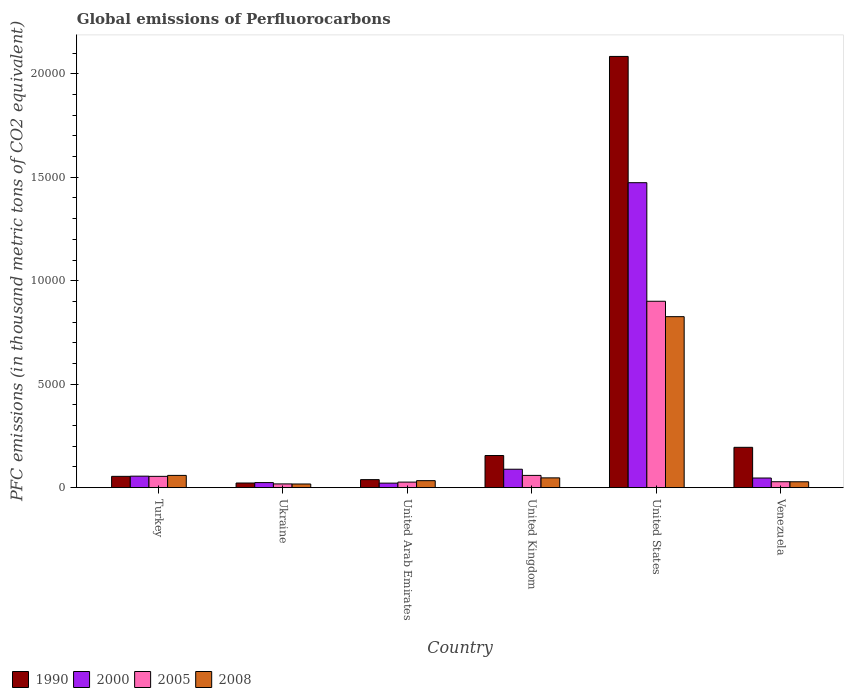How many different coloured bars are there?
Your response must be concise. 4. How many bars are there on the 1st tick from the right?
Offer a terse response. 4. What is the global emissions of Perfluorocarbons in 1990 in United Arab Emirates?
Provide a succinct answer. 387.3. Across all countries, what is the maximum global emissions of Perfluorocarbons in 2008?
Your response must be concise. 8264. Across all countries, what is the minimum global emissions of Perfluorocarbons in 2005?
Give a very brief answer. 180.5. In which country was the global emissions of Perfluorocarbons in 2005 minimum?
Offer a very short reply. Ukraine. What is the total global emissions of Perfluorocarbons in 2008 in the graph?
Give a very brief answer. 1.01e+04. What is the difference between the global emissions of Perfluorocarbons in 2008 in Turkey and that in United Kingdom?
Your answer should be very brief. 119. What is the difference between the global emissions of Perfluorocarbons in 2005 in United Arab Emirates and the global emissions of Perfluorocarbons in 2000 in Turkey?
Your answer should be very brief. -287. What is the average global emissions of Perfluorocarbons in 2005 per country?
Make the answer very short. 1813.42. What is the ratio of the global emissions of Perfluorocarbons in 2005 in United Arab Emirates to that in Venezuela?
Offer a terse response. 0.94. Is the global emissions of Perfluorocarbons in 2008 in United Arab Emirates less than that in United Kingdom?
Offer a terse response. Yes. Is the difference between the global emissions of Perfluorocarbons in 2000 in United Kingdom and Venezuela greater than the difference between the global emissions of Perfluorocarbons in 2005 in United Kingdom and Venezuela?
Your answer should be compact. Yes. What is the difference between the highest and the second highest global emissions of Perfluorocarbons in 2005?
Provide a short and direct response. 8462.8. What is the difference between the highest and the lowest global emissions of Perfluorocarbons in 2000?
Your answer should be very brief. 1.45e+04. In how many countries, is the global emissions of Perfluorocarbons in 2008 greater than the average global emissions of Perfluorocarbons in 2008 taken over all countries?
Your answer should be compact. 1. Is the sum of the global emissions of Perfluorocarbons in 2008 in United Arab Emirates and United States greater than the maximum global emissions of Perfluorocarbons in 1990 across all countries?
Your answer should be compact. No. Is it the case that in every country, the sum of the global emissions of Perfluorocarbons in 2008 and global emissions of Perfluorocarbons in 1990 is greater than the sum of global emissions of Perfluorocarbons in 2000 and global emissions of Perfluorocarbons in 2005?
Your answer should be compact. No. What does the 1st bar from the left in Venezuela represents?
Make the answer very short. 1990. What does the 4th bar from the right in Venezuela represents?
Provide a short and direct response. 1990. How many bars are there?
Your answer should be compact. 24. How many countries are there in the graph?
Ensure brevity in your answer.  6. What is the difference between two consecutive major ticks on the Y-axis?
Your answer should be very brief. 5000. Are the values on the major ticks of Y-axis written in scientific E-notation?
Offer a very short reply. No. Where does the legend appear in the graph?
Your answer should be compact. Bottom left. How many legend labels are there?
Provide a succinct answer. 4. How are the legend labels stacked?
Your answer should be compact. Horizontal. What is the title of the graph?
Your answer should be very brief. Global emissions of Perfluorocarbons. Does "1969" appear as one of the legend labels in the graph?
Offer a very short reply. No. What is the label or title of the X-axis?
Your answer should be very brief. Country. What is the label or title of the Y-axis?
Ensure brevity in your answer.  PFC emissions (in thousand metric tons of CO2 equivalent). What is the PFC emissions (in thousand metric tons of CO2 equivalent) of 1990 in Turkey?
Offer a terse response. 545.6. What is the PFC emissions (in thousand metric tons of CO2 equivalent) in 2000 in Turkey?
Provide a succinct answer. 554.9. What is the PFC emissions (in thousand metric tons of CO2 equivalent) of 2005 in Turkey?
Offer a very short reply. 545.9. What is the PFC emissions (in thousand metric tons of CO2 equivalent) in 2008 in Turkey?
Offer a very short reply. 591.4. What is the PFC emissions (in thousand metric tons of CO2 equivalent) in 1990 in Ukraine?
Provide a succinct answer. 224. What is the PFC emissions (in thousand metric tons of CO2 equivalent) in 2000 in Ukraine?
Provide a short and direct response. 244.1. What is the PFC emissions (in thousand metric tons of CO2 equivalent) of 2005 in Ukraine?
Provide a short and direct response. 180.5. What is the PFC emissions (in thousand metric tons of CO2 equivalent) of 2008 in Ukraine?
Your response must be concise. 176.5. What is the PFC emissions (in thousand metric tons of CO2 equivalent) of 1990 in United Arab Emirates?
Your answer should be compact. 387.3. What is the PFC emissions (in thousand metric tons of CO2 equivalent) of 2000 in United Arab Emirates?
Your answer should be compact. 218. What is the PFC emissions (in thousand metric tons of CO2 equivalent) of 2005 in United Arab Emirates?
Provide a succinct answer. 267.9. What is the PFC emissions (in thousand metric tons of CO2 equivalent) in 2008 in United Arab Emirates?
Your answer should be very brief. 337.6. What is the PFC emissions (in thousand metric tons of CO2 equivalent) in 1990 in United Kingdom?
Keep it short and to the point. 1552.5. What is the PFC emissions (in thousand metric tons of CO2 equivalent) of 2000 in United Kingdom?
Give a very brief answer. 890.1. What is the PFC emissions (in thousand metric tons of CO2 equivalent) of 2005 in United Kingdom?
Keep it short and to the point. 591.4. What is the PFC emissions (in thousand metric tons of CO2 equivalent) in 2008 in United Kingdom?
Your answer should be compact. 472.4. What is the PFC emissions (in thousand metric tons of CO2 equivalent) in 1990 in United States?
Your response must be concise. 2.08e+04. What is the PFC emissions (in thousand metric tons of CO2 equivalent) in 2000 in United States?
Offer a terse response. 1.47e+04. What is the PFC emissions (in thousand metric tons of CO2 equivalent) in 2005 in United States?
Provide a short and direct response. 9008.7. What is the PFC emissions (in thousand metric tons of CO2 equivalent) of 2008 in United States?
Provide a succinct answer. 8264. What is the PFC emissions (in thousand metric tons of CO2 equivalent) in 1990 in Venezuela?
Your answer should be compact. 1948.7. What is the PFC emissions (in thousand metric tons of CO2 equivalent) of 2000 in Venezuela?
Provide a short and direct response. 464.6. What is the PFC emissions (in thousand metric tons of CO2 equivalent) of 2005 in Venezuela?
Your answer should be compact. 286.1. What is the PFC emissions (in thousand metric tons of CO2 equivalent) in 2008 in Venezuela?
Provide a short and direct response. 283.8. Across all countries, what is the maximum PFC emissions (in thousand metric tons of CO2 equivalent) of 1990?
Your answer should be compact. 2.08e+04. Across all countries, what is the maximum PFC emissions (in thousand metric tons of CO2 equivalent) in 2000?
Keep it short and to the point. 1.47e+04. Across all countries, what is the maximum PFC emissions (in thousand metric tons of CO2 equivalent) of 2005?
Ensure brevity in your answer.  9008.7. Across all countries, what is the maximum PFC emissions (in thousand metric tons of CO2 equivalent) in 2008?
Ensure brevity in your answer.  8264. Across all countries, what is the minimum PFC emissions (in thousand metric tons of CO2 equivalent) in 1990?
Your answer should be very brief. 224. Across all countries, what is the minimum PFC emissions (in thousand metric tons of CO2 equivalent) of 2000?
Your answer should be compact. 218. Across all countries, what is the minimum PFC emissions (in thousand metric tons of CO2 equivalent) in 2005?
Your response must be concise. 180.5. Across all countries, what is the minimum PFC emissions (in thousand metric tons of CO2 equivalent) in 2008?
Your answer should be very brief. 176.5. What is the total PFC emissions (in thousand metric tons of CO2 equivalent) of 1990 in the graph?
Make the answer very short. 2.55e+04. What is the total PFC emissions (in thousand metric tons of CO2 equivalent) of 2000 in the graph?
Provide a short and direct response. 1.71e+04. What is the total PFC emissions (in thousand metric tons of CO2 equivalent) of 2005 in the graph?
Your response must be concise. 1.09e+04. What is the total PFC emissions (in thousand metric tons of CO2 equivalent) of 2008 in the graph?
Keep it short and to the point. 1.01e+04. What is the difference between the PFC emissions (in thousand metric tons of CO2 equivalent) of 1990 in Turkey and that in Ukraine?
Give a very brief answer. 321.6. What is the difference between the PFC emissions (in thousand metric tons of CO2 equivalent) of 2000 in Turkey and that in Ukraine?
Offer a very short reply. 310.8. What is the difference between the PFC emissions (in thousand metric tons of CO2 equivalent) of 2005 in Turkey and that in Ukraine?
Keep it short and to the point. 365.4. What is the difference between the PFC emissions (in thousand metric tons of CO2 equivalent) in 2008 in Turkey and that in Ukraine?
Offer a very short reply. 414.9. What is the difference between the PFC emissions (in thousand metric tons of CO2 equivalent) of 1990 in Turkey and that in United Arab Emirates?
Ensure brevity in your answer.  158.3. What is the difference between the PFC emissions (in thousand metric tons of CO2 equivalent) in 2000 in Turkey and that in United Arab Emirates?
Ensure brevity in your answer.  336.9. What is the difference between the PFC emissions (in thousand metric tons of CO2 equivalent) in 2005 in Turkey and that in United Arab Emirates?
Offer a terse response. 278. What is the difference between the PFC emissions (in thousand metric tons of CO2 equivalent) in 2008 in Turkey and that in United Arab Emirates?
Offer a terse response. 253.8. What is the difference between the PFC emissions (in thousand metric tons of CO2 equivalent) in 1990 in Turkey and that in United Kingdom?
Your answer should be compact. -1006.9. What is the difference between the PFC emissions (in thousand metric tons of CO2 equivalent) in 2000 in Turkey and that in United Kingdom?
Give a very brief answer. -335.2. What is the difference between the PFC emissions (in thousand metric tons of CO2 equivalent) of 2005 in Turkey and that in United Kingdom?
Provide a short and direct response. -45.5. What is the difference between the PFC emissions (in thousand metric tons of CO2 equivalent) in 2008 in Turkey and that in United Kingdom?
Provide a short and direct response. 119. What is the difference between the PFC emissions (in thousand metric tons of CO2 equivalent) in 1990 in Turkey and that in United States?
Ensure brevity in your answer.  -2.03e+04. What is the difference between the PFC emissions (in thousand metric tons of CO2 equivalent) in 2000 in Turkey and that in United States?
Keep it short and to the point. -1.42e+04. What is the difference between the PFC emissions (in thousand metric tons of CO2 equivalent) of 2005 in Turkey and that in United States?
Your answer should be compact. -8462.8. What is the difference between the PFC emissions (in thousand metric tons of CO2 equivalent) in 2008 in Turkey and that in United States?
Give a very brief answer. -7672.6. What is the difference between the PFC emissions (in thousand metric tons of CO2 equivalent) of 1990 in Turkey and that in Venezuela?
Provide a short and direct response. -1403.1. What is the difference between the PFC emissions (in thousand metric tons of CO2 equivalent) of 2000 in Turkey and that in Venezuela?
Provide a short and direct response. 90.3. What is the difference between the PFC emissions (in thousand metric tons of CO2 equivalent) of 2005 in Turkey and that in Venezuela?
Make the answer very short. 259.8. What is the difference between the PFC emissions (in thousand metric tons of CO2 equivalent) in 2008 in Turkey and that in Venezuela?
Give a very brief answer. 307.6. What is the difference between the PFC emissions (in thousand metric tons of CO2 equivalent) in 1990 in Ukraine and that in United Arab Emirates?
Offer a very short reply. -163.3. What is the difference between the PFC emissions (in thousand metric tons of CO2 equivalent) in 2000 in Ukraine and that in United Arab Emirates?
Ensure brevity in your answer.  26.1. What is the difference between the PFC emissions (in thousand metric tons of CO2 equivalent) of 2005 in Ukraine and that in United Arab Emirates?
Provide a succinct answer. -87.4. What is the difference between the PFC emissions (in thousand metric tons of CO2 equivalent) of 2008 in Ukraine and that in United Arab Emirates?
Your answer should be very brief. -161.1. What is the difference between the PFC emissions (in thousand metric tons of CO2 equivalent) in 1990 in Ukraine and that in United Kingdom?
Your answer should be very brief. -1328.5. What is the difference between the PFC emissions (in thousand metric tons of CO2 equivalent) of 2000 in Ukraine and that in United Kingdom?
Provide a succinct answer. -646. What is the difference between the PFC emissions (in thousand metric tons of CO2 equivalent) of 2005 in Ukraine and that in United Kingdom?
Your response must be concise. -410.9. What is the difference between the PFC emissions (in thousand metric tons of CO2 equivalent) in 2008 in Ukraine and that in United Kingdom?
Your answer should be compact. -295.9. What is the difference between the PFC emissions (in thousand metric tons of CO2 equivalent) in 1990 in Ukraine and that in United States?
Ensure brevity in your answer.  -2.06e+04. What is the difference between the PFC emissions (in thousand metric tons of CO2 equivalent) of 2000 in Ukraine and that in United States?
Your answer should be very brief. -1.45e+04. What is the difference between the PFC emissions (in thousand metric tons of CO2 equivalent) in 2005 in Ukraine and that in United States?
Ensure brevity in your answer.  -8828.2. What is the difference between the PFC emissions (in thousand metric tons of CO2 equivalent) in 2008 in Ukraine and that in United States?
Ensure brevity in your answer.  -8087.5. What is the difference between the PFC emissions (in thousand metric tons of CO2 equivalent) in 1990 in Ukraine and that in Venezuela?
Your answer should be very brief. -1724.7. What is the difference between the PFC emissions (in thousand metric tons of CO2 equivalent) of 2000 in Ukraine and that in Venezuela?
Your response must be concise. -220.5. What is the difference between the PFC emissions (in thousand metric tons of CO2 equivalent) of 2005 in Ukraine and that in Venezuela?
Provide a succinct answer. -105.6. What is the difference between the PFC emissions (in thousand metric tons of CO2 equivalent) of 2008 in Ukraine and that in Venezuela?
Your answer should be very brief. -107.3. What is the difference between the PFC emissions (in thousand metric tons of CO2 equivalent) of 1990 in United Arab Emirates and that in United Kingdom?
Ensure brevity in your answer.  -1165.2. What is the difference between the PFC emissions (in thousand metric tons of CO2 equivalent) in 2000 in United Arab Emirates and that in United Kingdom?
Provide a succinct answer. -672.1. What is the difference between the PFC emissions (in thousand metric tons of CO2 equivalent) of 2005 in United Arab Emirates and that in United Kingdom?
Provide a short and direct response. -323.5. What is the difference between the PFC emissions (in thousand metric tons of CO2 equivalent) in 2008 in United Arab Emirates and that in United Kingdom?
Provide a succinct answer. -134.8. What is the difference between the PFC emissions (in thousand metric tons of CO2 equivalent) of 1990 in United Arab Emirates and that in United States?
Provide a short and direct response. -2.05e+04. What is the difference between the PFC emissions (in thousand metric tons of CO2 equivalent) of 2000 in United Arab Emirates and that in United States?
Keep it short and to the point. -1.45e+04. What is the difference between the PFC emissions (in thousand metric tons of CO2 equivalent) in 2005 in United Arab Emirates and that in United States?
Offer a terse response. -8740.8. What is the difference between the PFC emissions (in thousand metric tons of CO2 equivalent) in 2008 in United Arab Emirates and that in United States?
Offer a very short reply. -7926.4. What is the difference between the PFC emissions (in thousand metric tons of CO2 equivalent) of 1990 in United Arab Emirates and that in Venezuela?
Provide a short and direct response. -1561.4. What is the difference between the PFC emissions (in thousand metric tons of CO2 equivalent) in 2000 in United Arab Emirates and that in Venezuela?
Ensure brevity in your answer.  -246.6. What is the difference between the PFC emissions (in thousand metric tons of CO2 equivalent) of 2005 in United Arab Emirates and that in Venezuela?
Keep it short and to the point. -18.2. What is the difference between the PFC emissions (in thousand metric tons of CO2 equivalent) of 2008 in United Arab Emirates and that in Venezuela?
Your response must be concise. 53.8. What is the difference between the PFC emissions (in thousand metric tons of CO2 equivalent) in 1990 in United Kingdom and that in United States?
Your answer should be compact. -1.93e+04. What is the difference between the PFC emissions (in thousand metric tons of CO2 equivalent) in 2000 in United Kingdom and that in United States?
Provide a short and direct response. -1.38e+04. What is the difference between the PFC emissions (in thousand metric tons of CO2 equivalent) in 2005 in United Kingdom and that in United States?
Provide a short and direct response. -8417.3. What is the difference between the PFC emissions (in thousand metric tons of CO2 equivalent) in 2008 in United Kingdom and that in United States?
Provide a succinct answer. -7791.6. What is the difference between the PFC emissions (in thousand metric tons of CO2 equivalent) in 1990 in United Kingdom and that in Venezuela?
Provide a succinct answer. -396.2. What is the difference between the PFC emissions (in thousand metric tons of CO2 equivalent) of 2000 in United Kingdom and that in Venezuela?
Your answer should be compact. 425.5. What is the difference between the PFC emissions (in thousand metric tons of CO2 equivalent) of 2005 in United Kingdom and that in Venezuela?
Make the answer very short. 305.3. What is the difference between the PFC emissions (in thousand metric tons of CO2 equivalent) of 2008 in United Kingdom and that in Venezuela?
Keep it short and to the point. 188.6. What is the difference between the PFC emissions (in thousand metric tons of CO2 equivalent) of 1990 in United States and that in Venezuela?
Keep it short and to the point. 1.89e+04. What is the difference between the PFC emissions (in thousand metric tons of CO2 equivalent) of 2000 in United States and that in Venezuela?
Ensure brevity in your answer.  1.43e+04. What is the difference between the PFC emissions (in thousand metric tons of CO2 equivalent) of 2005 in United States and that in Venezuela?
Your response must be concise. 8722.6. What is the difference between the PFC emissions (in thousand metric tons of CO2 equivalent) of 2008 in United States and that in Venezuela?
Keep it short and to the point. 7980.2. What is the difference between the PFC emissions (in thousand metric tons of CO2 equivalent) in 1990 in Turkey and the PFC emissions (in thousand metric tons of CO2 equivalent) in 2000 in Ukraine?
Your answer should be compact. 301.5. What is the difference between the PFC emissions (in thousand metric tons of CO2 equivalent) in 1990 in Turkey and the PFC emissions (in thousand metric tons of CO2 equivalent) in 2005 in Ukraine?
Make the answer very short. 365.1. What is the difference between the PFC emissions (in thousand metric tons of CO2 equivalent) of 1990 in Turkey and the PFC emissions (in thousand metric tons of CO2 equivalent) of 2008 in Ukraine?
Your answer should be compact. 369.1. What is the difference between the PFC emissions (in thousand metric tons of CO2 equivalent) in 2000 in Turkey and the PFC emissions (in thousand metric tons of CO2 equivalent) in 2005 in Ukraine?
Provide a succinct answer. 374.4. What is the difference between the PFC emissions (in thousand metric tons of CO2 equivalent) of 2000 in Turkey and the PFC emissions (in thousand metric tons of CO2 equivalent) of 2008 in Ukraine?
Provide a short and direct response. 378.4. What is the difference between the PFC emissions (in thousand metric tons of CO2 equivalent) of 2005 in Turkey and the PFC emissions (in thousand metric tons of CO2 equivalent) of 2008 in Ukraine?
Your response must be concise. 369.4. What is the difference between the PFC emissions (in thousand metric tons of CO2 equivalent) of 1990 in Turkey and the PFC emissions (in thousand metric tons of CO2 equivalent) of 2000 in United Arab Emirates?
Give a very brief answer. 327.6. What is the difference between the PFC emissions (in thousand metric tons of CO2 equivalent) in 1990 in Turkey and the PFC emissions (in thousand metric tons of CO2 equivalent) in 2005 in United Arab Emirates?
Your answer should be very brief. 277.7. What is the difference between the PFC emissions (in thousand metric tons of CO2 equivalent) of 1990 in Turkey and the PFC emissions (in thousand metric tons of CO2 equivalent) of 2008 in United Arab Emirates?
Your response must be concise. 208. What is the difference between the PFC emissions (in thousand metric tons of CO2 equivalent) in 2000 in Turkey and the PFC emissions (in thousand metric tons of CO2 equivalent) in 2005 in United Arab Emirates?
Ensure brevity in your answer.  287. What is the difference between the PFC emissions (in thousand metric tons of CO2 equivalent) of 2000 in Turkey and the PFC emissions (in thousand metric tons of CO2 equivalent) of 2008 in United Arab Emirates?
Your answer should be very brief. 217.3. What is the difference between the PFC emissions (in thousand metric tons of CO2 equivalent) in 2005 in Turkey and the PFC emissions (in thousand metric tons of CO2 equivalent) in 2008 in United Arab Emirates?
Offer a terse response. 208.3. What is the difference between the PFC emissions (in thousand metric tons of CO2 equivalent) of 1990 in Turkey and the PFC emissions (in thousand metric tons of CO2 equivalent) of 2000 in United Kingdom?
Your answer should be compact. -344.5. What is the difference between the PFC emissions (in thousand metric tons of CO2 equivalent) of 1990 in Turkey and the PFC emissions (in thousand metric tons of CO2 equivalent) of 2005 in United Kingdom?
Offer a terse response. -45.8. What is the difference between the PFC emissions (in thousand metric tons of CO2 equivalent) of 1990 in Turkey and the PFC emissions (in thousand metric tons of CO2 equivalent) of 2008 in United Kingdom?
Provide a short and direct response. 73.2. What is the difference between the PFC emissions (in thousand metric tons of CO2 equivalent) of 2000 in Turkey and the PFC emissions (in thousand metric tons of CO2 equivalent) of 2005 in United Kingdom?
Your answer should be very brief. -36.5. What is the difference between the PFC emissions (in thousand metric tons of CO2 equivalent) of 2000 in Turkey and the PFC emissions (in thousand metric tons of CO2 equivalent) of 2008 in United Kingdom?
Keep it short and to the point. 82.5. What is the difference between the PFC emissions (in thousand metric tons of CO2 equivalent) in 2005 in Turkey and the PFC emissions (in thousand metric tons of CO2 equivalent) in 2008 in United Kingdom?
Ensure brevity in your answer.  73.5. What is the difference between the PFC emissions (in thousand metric tons of CO2 equivalent) in 1990 in Turkey and the PFC emissions (in thousand metric tons of CO2 equivalent) in 2000 in United States?
Offer a very short reply. -1.42e+04. What is the difference between the PFC emissions (in thousand metric tons of CO2 equivalent) of 1990 in Turkey and the PFC emissions (in thousand metric tons of CO2 equivalent) of 2005 in United States?
Make the answer very short. -8463.1. What is the difference between the PFC emissions (in thousand metric tons of CO2 equivalent) in 1990 in Turkey and the PFC emissions (in thousand metric tons of CO2 equivalent) in 2008 in United States?
Give a very brief answer. -7718.4. What is the difference between the PFC emissions (in thousand metric tons of CO2 equivalent) in 2000 in Turkey and the PFC emissions (in thousand metric tons of CO2 equivalent) in 2005 in United States?
Offer a very short reply. -8453.8. What is the difference between the PFC emissions (in thousand metric tons of CO2 equivalent) of 2000 in Turkey and the PFC emissions (in thousand metric tons of CO2 equivalent) of 2008 in United States?
Make the answer very short. -7709.1. What is the difference between the PFC emissions (in thousand metric tons of CO2 equivalent) of 2005 in Turkey and the PFC emissions (in thousand metric tons of CO2 equivalent) of 2008 in United States?
Your answer should be compact. -7718.1. What is the difference between the PFC emissions (in thousand metric tons of CO2 equivalent) of 1990 in Turkey and the PFC emissions (in thousand metric tons of CO2 equivalent) of 2005 in Venezuela?
Your response must be concise. 259.5. What is the difference between the PFC emissions (in thousand metric tons of CO2 equivalent) in 1990 in Turkey and the PFC emissions (in thousand metric tons of CO2 equivalent) in 2008 in Venezuela?
Ensure brevity in your answer.  261.8. What is the difference between the PFC emissions (in thousand metric tons of CO2 equivalent) of 2000 in Turkey and the PFC emissions (in thousand metric tons of CO2 equivalent) of 2005 in Venezuela?
Your answer should be compact. 268.8. What is the difference between the PFC emissions (in thousand metric tons of CO2 equivalent) of 2000 in Turkey and the PFC emissions (in thousand metric tons of CO2 equivalent) of 2008 in Venezuela?
Your response must be concise. 271.1. What is the difference between the PFC emissions (in thousand metric tons of CO2 equivalent) of 2005 in Turkey and the PFC emissions (in thousand metric tons of CO2 equivalent) of 2008 in Venezuela?
Keep it short and to the point. 262.1. What is the difference between the PFC emissions (in thousand metric tons of CO2 equivalent) in 1990 in Ukraine and the PFC emissions (in thousand metric tons of CO2 equivalent) in 2005 in United Arab Emirates?
Make the answer very short. -43.9. What is the difference between the PFC emissions (in thousand metric tons of CO2 equivalent) of 1990 in Ukraine and the PFC emissions (in thousand metric tons of CO2 equivalent) of 2008 in United Arab Emirates?
Offer a terse response. -113.6. What is the difference between the PFC emissions (in thousand metric tons of CO2 equivalent) in 2000 in Ukraine and the PFC emissions (in thousand metric tons of CO2 equivalent) in 2005 in United Arab Emirates?
Provide a short and direct response. -23.8. What is the difference between the PFC emissions (in thousand metric tons of CO2 equivalent) of 2000 in Ukraine and the PFC emissions (in thousand metric tons of CO2 equivalent) of 2008 in United Arab Emirates?
Give a very brief answer. -93.5. What is the difference between the PFC emissions (in thousand metric tons of CO2 equivalent) of 2005 in Ukraine and the PFC emissions (in thousand metric tons of CO2 equivalent) of 2008 in United Arab Emirates?
Make the answer very short. -157.1. What is the difference between the PFC emissions (in thousand metric tons of CO2 equivalent) in 1990 in Ukraine and the PFC emissions (in thousand metric tons of CO2 equivalent) in 2000 in United Kingdom?
Your response must be concise. -666.1. What is the difference between the PFC emissions (in thousand metric tons of CO2 equivalent) of 1990 in Ukraine and the PFC emissions (in thousand metric tons of CO2 equivalent) of 2005 in United Kingdom?
Offer a very short reply. -367.4. What is the difference between the PFC emissions (in thousand metric tons of CO2 equivalent) in 1990 in Ukraine and the PFC emissions (in thousand metric tons of CO2 equivalent) in 2008 in United Kingdom?
Provide a succinct answer. -248.4. What is the difference between the PFC emissions (in thousand metric tons of CO2 equivalent) in 2000 in Ukraine and the PFC emissions (in thousand metric tons of CO2 equivalent) in 2005 in United Kingdom?
Provide a succinct answer. -347.3. What is the difference between the PFC emissions (in thousand metric tons of CO2 equivalent) of 2000 in Ukraine and the PFC emissions (in thousand metric tons of CO2 equivalent) of 2008 in United Kingdom?
Offer a very short reply. -228.3. What is the difference between the PFC emissions (in thousand metric tons of CO2 equivalent) in 2005 in Ukraine and the PFC emissions (in thousand metric tons of CO2 equivalent) in 2008 in United Kingdom?
Offer a terse response. -291.9. What is the difference between the PFC emissions (in thousand metric tons of CO2 equivalent) in 1990 in Ukraine and the PFC emissions (in thousand metric tons of CO2 equivalent) in 2000 in United States?
Provide a short and direct response. -1.45e+04. What is the difference between the PFC emissions (in thousand metric tons of CO2 equivalent) of 1990 in Ukraine and the PFC emissions (in thousand metric tons of CO2 equivalent) of 2005 in United States?
Your response must be concise. -8784.7. What is the difference between the PFC emissions (in thousand metric tons of CO2 equivalent) of 1990 in Ukraine and the PFC emissions (in thousand metric tons of CO2 equivalent) of 2008 in United States?
Your response must be concise. -8040. What is the difference between the PFC emissions (in thousand metric tons of CO2 equivalent) of 2000 in Ukraine and the PFC emissions (in thousand metric tons of CO2 equivalent) of 2005 in United States?
Offer a terse response. -8764.6. What is the difference between the PFC emissions (in thousand metric tons of CO2 equivalent) of 2000 in Ukraine and the PFC emissions (in thousand metric tons of CO2 equivalent) of 2008 in United States?
Provide a succinct answer. -8019.9. What is the difference between the PFC emissions (in thousand metric tons of CO2 equivalent) of 2005 in Ukraine and the PFC emissions (in thousand metric tons of CO2 equivalent) of 2008 in United States?
Make the answer very short. -8083.5. What is the difference between the PFC emissions (in thousand metric tons of CO2 equivalent) in 1990 in Ukraine and the PFC emissions (in thousand metric tons of CO2 equivalent) in 2000 in Venezuela?
Offer a very short reply. -240.6. What is the difference between the PFC emissions (in thousand metric tons of CO2 equivalent) of 1990 in Ukraine and the PFC emissions (in thousand metric tons of CO2 equivalent) of 2005 in Venezuela?
Provide a short and direct response. -62.1. What is the difference between the PFC emissions (in thousand metric tons of CO2 equivalent) in 1990 in Ukraine and the PFC emissions (in thousand metric tons of CO2 equivalent) in 2008 in Venezuela?
Give a very brief answer. -59.8. What is the difference between the PFC emissions (in thousand metric tons of CO2 equivalent) of 2000 in Ukraine and the PFC emissions (in thousand metric tons of CO2 equivalent) of 2005 in Venezuela?
Offer a very short reply. -42. What is the difference between the PFC emissions (in thousand metric tons of CO2 equivalent) in 2000 in Ukraine and the PFC emissions (in thousand metric tons of CO2 equivalent) in 2008 in Venezuela?
Offer a terse response. -39.7. What is the difference between the PFC emissions (in thousand metric tons of CO2 equivalent) of 2005 in Ukraine and the PFC emissions (in thousand metric tons of CO2 equivalent) of 2008 in Venezuela?
Give a very brief answer. -103.3. What is the difference between the PFC emissions (in thousand metric tons of CO2 equivalent) in 1990 in United Arab Emirates and the PFC emissions (in thousand metric tons of CO2 equivalent) in 2000 in United Kingdom?
Your answer should be very brief. -502.8. What is the difference between the PFC emissions (in thousand metric tons of CO2 equivalent) in 1990 in United Arab Emirates and the PFC emissions (in thousand metric tons of CO2 equivalent) in 2005 in United Kingdom?
Keep it short and to the point. -204.1. What is the difference between the PFC emissions (in thousand metric tons of CO2 equivalent) in 1990 in United Arab Emirates and the PFC emissions (in thousand metric tons of CO2 equivalent) in 2008 in United Kingdom?
Your answer should be very brief. -85.1. What is the difference between the PFC emissions (in thousand metric tons of CO2 equivalent) in 2000 in United Arab Emirates and the PFC emissions (in thousand metric tons of CO2 equivalent) in 2005 in United Kingdom?
Give a very brief answer. -373.4. What is the difference between the PFC emissions (in thousand metric tons of CO2 equivalent) of 2000 in United Arab Emirates and the PFC emissions (in thousand metric tons of CO2 equivalent) of 2008 in United Kingdom?
Your answer should be compact. -254.4. What is the difference between the PFC emissions (in thousand metric tons of CO2 equivalent) in 2005 in United Arab Emirates and the PFC emissions (in thousand metric tons of CO2 equivalent) in 2008 in United Kingdom?
Give a very brief answer. -204.5. What is the difference between the PFC emissions (in thousand metric tons of CO2 equivalent) in 1990 in United Arab Emirates and the PFC emissions (in thousand metric tons of CO2 equivalent) in 2000 in United States?
Your response must be concise. -1.44e+04. What is the difference between the PFC emissions (in thousand metric tons of CO2 equivalent) of 1990 in United Arab Emirates and the PFC emissions (in thousand metric tons of CO2 equivalent) of 2005 in United States?
Provide a short and direct response. -8621.4. What is the difference between the PFC emissions (in thousand metric tons of CO2 equivalent) in 1990 in United Arab Emirates and the PFC emissions (in thousand metric tons of CO2 equivalent) in 2008 in United States?
Ensure brevity in your answer.  -7876.7. What is the difference between the PFC emissions (in thousand metric tons of CO2 equivalent) in 2000 in United Arab Emirates and the PFC emissions (in thousand metric tons of CO2 equivalent) in 2005 in United States?
Offer a very short reply. -8790.7. What is the difference between the PFC emissions (in thousand metric tons of CO2 equivalent) in 2000 in United Arab Emirates and the PFC emissions (in thousand metric tons of CO2 equivalent) in 2008 in United States?
Provide a short and direct response. -8046. What is the difference between the PFC emissions (in thousand metric tons of CO2 equivalent) of 2005 in United Arab Emirates and the PFC emissions (in thousand metric tons of CO2 equivalent) of 2008 in United States?
Provide a short and direct response. -7996.1. What is the difference between the PFC emissions (in thousand metric tons of CO2 equivalent) in 1990 in United Arab Emirates and the PFC emissions (in thousand metric tons of CO2 equivalent) in 2000 in Venezuela?
Give a very brief answer. -77.3. What is the difference between the PFC emissions (in thousand metric tons of CO2 equivalent) of 1990 in United Arab Emirates and the PFC emissions (in thousand metric tons of CO2 equivalent) of 2005 in Venezuela?
Your answer should be very brief. 101.2. What is the difference between the PFC emissions (in thousand metric tons of CO2 equivalent) in 1990 in United Arab Emirates and the PFC emissions (in thousand metric tons of CO2 equivalent) in 2008 in Venezuela?
Your answer should be very brief. 103.5. What is the difference between the PFC emissions (in thousand metric tons of CO2 equivalent) in 2000 in United Arab Emirates and the PFC emissions (in thousand metric tons of CO2 equivalent) in 2005 in Venezuela?
Offer a terse response. -68.1. What is the difference between the PFC emissions (in thousand metric tons of CO2 equivalent) of 2000 in United Arab Emirates and the PFC emissions (in thousand metric tons of CO2 equivalent) of 2008 in Venezuela?
Keep it short and to the point. -65.8. What is the difference between the PFC emissions (in thousand metric tons of CO2 equivalent) of 2005 in United Arab Emirates and the PFC emissions (in thousand metric tons of CO2 equivalent) of 2008 in Venezuela?
Ensure brevity in your answer.  -15.9. What is the difference between the PFC emissions (in thousand metric tons of CO2 equivalent) of 1990 in United Kingdom and the PFC emissions (in thousand metric tons of CO2 equivalent) of 2000 in United States?
Your answer should be compact. -1.32e+04. What is the difference between the PFC emissions (in thousand metric tons of CO2 equivalent) in 1990 in United Kingdom and the PFC emissions (in thousand metric tons of CO2 equivalent) in 2005 in United States?
Offer a terse response. -7456.2. What is the difference between the PFC emissions (in thousand metric tons of CO2 equivalent) in 1990 in United Kingdom and the PFC emissions (in thousand metric tons of CO2 equivalent) in 2008 in United States?
Offer a very short reply. -6711.5. What is the difference between the PFC emissions (in thousand metric tons of CO2 equivalent) of 2000 in United Kingdom and the PFC emissions (in thousand metric tons of CO2 equivalent) of 2005 in United States?
Ensure brevity in your answer.  -8118.6. What is the difference between the PFC emissions (in thousand metric tons of CO2 equivalent) of 2000 in United Kingdom and the PFC emissions (in thousand metric tons of CO2 equivalent) of 2008 in United States?
Ensure brevity in your answer.  -7373.9. What is the difference between the PFC emissions (in thousand metric tons of CO2 equivalent) in 2005 in United Kingdom and the PFC emissions (in thousand metric tons of CO2 equivalent) in 2008 in United States?
Offer a very short reply. -7672.6. What is the difference between the PFC emissions (in thousand metric tons of CO2 equivalent) of 1990 in United Kingdom and the PFC emissions (in thousand metric tons of CO2 equivalent) of 2000 in Venezuela?
Provide a short and direct response. 1087.9. What is the difference between the PFC emissions (in thousand metric tons of CO2 equivalent) in 1990 in United Kingdom and the PFC emissions (in thousand metric tons of CO2 equivalent) in 2005 in Venezuela?
Your answer should be compact. 1266.4. What is the difference between the PFC emissions (in thousand metric tons of CO2 equivalent) of 1990 in United Kingdom and the PFC emissions (in thousand metric tons of CO2 equivalent) of 2008 in Venezuela?
Ensure brevity in your answer.  1268.7. What is the difference between the PFC emissions (in thousand metric tons of CO2 equivalent) in 2000 in United Kingdom and the PFC emissions (in thousand metric tons of CO2 equivalent) in 2005 in Venezuela?
Offer a very short reply. 604. What is the difference between the PFC emissions (in thousand metric tons of CO2 equivalent) of 2000 in United Kingdom and the PFC emissions (in thousand metric tons of CO2 equivalent) of 2008 in Venezuela?
Offer a terse response. 606.3. What is the difference between the PFC emissions (in thousand metric tons of CO2 equivalent) in 2005 in United Kingdom and the PFC emissions (in thousand metric tons of CO2 equivalent) in 2008 in Venezuela?
Provide a succinct answer. 307.6. What is the difference between the PFC emissions (in thousand metric tons of CO2 equivalent) in 1990 in United States and the PFC emissions (in thousand metric tons of CO2 equivalent) in 2000 in Venezuela?
Offer a terse response. 2.04e+04. What is the difference between the PFC emissions (in thousand metric tons of CO2 equivalent) in 1990 in United States and the PFC emissions (in thousand metric tons of CO2 equivalent) in 2005 in Venezuela?
Provide a short and direct response. 2.06e+04. What is the difference between the PFC emissions (in thousand metric tons of CO2 equivalent) in 1990 in United States and the PFC emissions (in thousand metric tons of CO2 equivalent) in 2008 in Venezuela?
Offer a terse response. 2.06e+04. What is the difference between the PFC emissions (in thousand metric tons of CO2 equivalent) of 2000 in United States and the PFC emissions (in thousand metric tons of CO2 equivalent) of 2005 in Venezuela?
Your answer should be compact. 1.45e+04. What is the difference between the PFC emissions (in thousand metric tons of CO2 equivalent) of 2000 in United States and the PFC emissions (in thousand metric tons of CO2 equivalent) of 2008 in Venezuela?
Make the answer very short. 1.45e+04. What is the difference between the PFC emissions (in thousand metric tons of CO2 equivalent) in 2005 in United States and the PFC emissions (in thousand metric tons of CO2 equivalent) in 2008 in Venezuela?
Give a very brief answer. 8724.9. What is the average PFC emissions (in thousand metric tons of CO2 equivalent) of 1990 per country?
Your answer should be very brief. 4249.9. What is the average PFC emissions (in thousand metric tons of CO2 equivalent) in 2000 per country?
Your response must be concise. 2851.78. What is the average PFC emissions (in thousand metric tons of CO2 equivalent) in 2005 per country?
Your response must be concise. 1813.42. What is the average PFC emissions (in thousand metric tons of CO2 equivalent) in 2008 per country?
Offer a very short reply. 1687.62. What is the difference between the PFC emissions (in thousand metric tons of CO2 equivalent) of 1990 and PFC emissions (in thousand metric tons of CO2 equivalent) of 2008 in Turkey?
Offer a terse response. -45.8. What is the difference between the PFC emissions (in thousand metric tons of CO2 equivalent) in 2000 and PFC emissions (in thousand metric tons of CO2 equivalent) in 2005 in Turkey?
Give a very brief answer. 9. What is the difference between the PFC emissions (in thousand metric tons of CO2 equivalent) in 2000 and PFC emissions (in thousand metric tons of CO2 equivalent) in 2008 in Turkey?
Keep it short and to the point. -36.5. What is the difference between the PFC emissions (in thousand metric tons of CO2 equivalent) in 2005 and PFC emissions (in thousand metric tons of CO2 equivalent) in 2008 in Turkey?
Provide a short and direct response. -45.5. What is the difference between the PFC emissions (in thousand metric tons of CO2 equivalent) of 1990 and PFC emissions (in thousand metric tons of CO2 equivalent) of 2000 in Ukraine?
Ensure brevity in your answer.  -20.1. What is the difference between the PFC emissions (in thousand metric tons of CO2 equivalent) of 1990 and PFC emissions (in thousand metric tons of CO2 equivalent) of 2005 in Ukraine?
Your response must be concise. 43.5. What is the difference between the PFC emissions (in thousand metric tons of CO2 equivalent) of 1990 and PFC emissions (in thousand metric tons of CO2 equivalent) of 2008 in Ukraine?
Make the answer very short. 47.5. What is the difference between the PFC emissions (in thousand metric tons of CO2 equivalent) in 2000 and PFC emissions (in thousand metric tons of CO2 equivalent) in 2005 in Ukraine?
Offer a terse response. 63.6. What is the difference between the PFC emissions (in thousand metric tons of CO2 equivalent) of 2000 and PFC emissions (in thousand metric tons of CO2 equivalent) of 2008 in Ukraine?
Your answer should be compact. 67.6. What is the difference between the PFC emissions (in thousand metric tons of CO2 equivalent) in 2005 and PFC emissions (in thousand metric tons of CO2 equivalent) in 2008 in Ukraine?
Keep it short and to the point. 4. What is the difference between the PFC emissions (in thousand metric tons of CO2 equivalent) of 1990 and PFC emissions (in thousand metric tons of CO2 equivalent) of 2000 in United Arab Emirates?
Provide a succinct answer. 169.3. What is the difference between the PFC emissions (in thousand metric tons of CO2 equivalent) of 1990 and PFC emissions (in thousand metric tons of CO2 equivalent) of 2005 in United Arab Emirates?
Ensure brevity in your answer.  119.4. What is the difference between the PFC emissions (in thousand metric tons of CO2 equivalent) in 1990 and PFC emissions (in thousand metric tons of CO2 equivalent) in 2008 in United Arab Emirates?
Offer a terse response. 49.7. What is the difference between the PFC emissions (in thousand metric tons of CO2 equivalent) in 2000 and PFC emissions (in thousand metric tons of CO2 equivalent) in 2005 in United Arab Emirates?
Your answer should be very brief. -49.9. What is the difference between the PFC emissions (in thousand metric tons of CO2 equivalent) of 2000 and PFC emissions (in thousand metric tons of CO2 equivalent) of 2008 in United Arab Emirates?
Provide a succinct answer. -119.6. What is the difference between the PFC emissions (in thousand metric tons of CO2 equivalent) of 2005 and PFC emissions (in thousand metric tons of CO2 equivalent) of 2008 in United Arab Emirates?
Provide a short and direct response. -69.7. What is the difference between the PFC emissions (in thousand metric tons of CO2 equivalent) of 1990 and PFC emissions (in thousand metric tons of CO2 equivalent) of 2000 in United Kingdom?
Your response must be concise. 662.4. What is the difference between the PFC emissions (in thousand metric tons of CO2 equivalent) of 1990 and PFC emissions (in thousand metric tons of CO2 equivalent) of 2005 in United Kingdom?
Offer a very short reply. 961.1. What is the difference between the PFC emissions (in thousand metric tons of CO2 equivalent) in 1990 and PFC emissions (in thousand metric tons of CO2 equivalent) in 2008 in United Kingdom?
Offer a terse response. 1080.1. What is the difference between the PFC emissions (in thousand metric tons of CO2 equivalent) in 2000 and PFC emissions (in thousand metric tons of CO2 equivalent) in 2005 in United Kingdom?
Your response must be concise. 298.7. What is the difference between the PFC emissions (in thousand metric tons of CO2 equivalent) of 2000 and PFC emissions (in thousand metric tons of CO2 equivalent) of 2008 in United Kingdom?
Your response must be concise. 417.7. What is the difference between the PFC emissions (in thousand metric tons of CO2 equivalent) in 2005 and PFC emissions (in thousand metric tons of CO2 equivalent) in 2008 in United Kingdom?
Your answer should be very brief. 119. What is the difference between the PFC emissions (in thousand metric tons of CO2 equivalent) of 1990 and PFC emissions (in thousand metric tons of CO2 equivalent) of 2000 in United States?
Offer a very short reply. 6102.3. What is the difference between the PFC emissions (in thousand metric tons of CO2 equivalent) in 1990 and PFC emissions (in thousand metric tons of CO2 equivalent) in 2005 in United States?
Ensure brevity in your answer.  1.18e+04. What is the difference between the PFC emissions (in thousand metric tons of CO2 equivalent) of 1990 and PFC emissions (in thousand metric tons of CO2 equivalent) of 2008 in United States?
Your answer should be very brief. 1.26e+04. What is the difference between the PFC emissions (in thousand metric tons of CO2 equivalent) of 2000 and PFC emissions (in thousand metric tons of CO2 equivalent) of 2005 in United States?
Your answer should be compact. 5730.3. What is the difference between the PFC emissions (in thousand metric tons of CO2 equivalent) of 2000 and PFC emissions (in thousand metric tons of CO2 equivalent) of 2008 in United States?
Provide a succinct answer. 6475. What is the difference between the PFC emissions (in thousand metric tons of CO2 equivalent) in 2005 and PFC emissions (in thousand metric tons of CO2 equivalent) in 2008 in United States?
Your response must be concise. 744.7. What is the difference between the PFC emissions (in thousand metric tons of CO2 equivalent) in 1990 and PFC emissions (in thousand metric tons of CO2 equivalent) in 2000 in Venezuela?
Your response must be concise. 1484.1. What is the difference between the PFC emissions (in thousand metric tons of CO2 equivalent) in 1990 and PFC emissions (in thousand metric tons of CO2 equivalent) in 2005 in Venezuela?
Provide a succinct answer. 1662.6. What is the difference between the PFC emissions (in thousand metric tons of CO2 equivalent) in 1990 and PFC emissions (in thousand metric tons of CO2 equivalent) in 2008 in Venezuela?
Your response must be concise. 1664.9. What is the difference between the PFC emissions (in thousand metric tons of CO2 equivalent) of 2000 and PFC emissions (in thousand metric tons of CO2 equivalent) of 2005 in Venezuela?
Keep it short and to the point. 178.5. What is the difference between the PFC emissions (in thousand metric tons of CO2 equivalent) of 2000 and PFC emissions (in thousand metric tons of CO2 equivalent) of 2008 in Venezuela?
Offer a terse response. 180.8. What is the difference between the PFC emissions (in thousand metric tons of CO2 equivalent) in 2005 and PFC emissions (in thousand metric tons of CO2 equivalent) in 2008 in Venezuela?
Offer a very short reply. 2.3. What is the ratio of the PFC emissions (in thousand metric tons of CO2 equivalent) in 1990 in Turkey to that in Ukraine?
Provide a short and direct response. 2.44. What is the ratio of the PFC emissions (in thousand metric tons of CO2 equivalent) in 2000 in Turkey to that in Ukraine?
Make the answer very short. 2.27. What is the ratio of the PFC emissions (in thousand metric tons of CO2 equivalent) of 2005 in Turkey to that in Ukraine?
Provide a short and direct response. 3.02. What is the ratio of the PFC emissions (in thousand metric tons of CO2 equivalent) of 2008 in Turkey to that in Ukraine?
Your answer should be very brief. 3.35. What is the ratio of the PFC emissions (in thousand metric tons of CO2 equivalent) of 1990 in Turkey to that in United Arab Emirates?
Ensure brevity in your answer.  1.41. What is the ratio of the PFC emissions (in thousand metric tons of CO2 equivalent) of 2000 in Turkey to that in United Arab Emirates?
Provide a succinct answer. 2.55. What is the ratio of the PFC emissions (in thousand metric tons of CO2 equivalent) of 2005 in Turkey to that in United Arab Emirates?
Make the answer very short. 2.04. What is the ratio of the PFC emissions (in thousand metric tons of CO2 equivalent) in 2008 in Turkey to that in United Arab Emirates?
Your answer should be compact. 1.75. What is the ratio of the PFC emissions (in thousand metric tons of CO2 equivalent) in 1990 in Turkey to that in United Kingdom?
Ensure brevity in your answer.  0.35. What is the ratio of the PFC emissions (in thousand metric tons of CO2 equivalent) of 2000 in Turkey to that in United Kingdom?
Make the answer very short. 0.62. What is the ratio of the PFC emissions (in thousand metric tons of CO2 equivalent) of 2005 in Turkey to that in United Kingdom?
Your answer should be compact. 0.92. What is the ratio of the PFC emissions (in thousand metric tons of CO2 equivalent) of 2008 in Turkey to that in United Kingdom?
Your answer should be compact. 1.25. What is the ratio of the PFC emissions (in thousand metric tons of CO2 equivalent) in 1990 in Turkey to that in United States?
Keep it short and to the point. 0.03. What is the ratio of the PFC emissions (in thousand metric tons of CO2 equivalent) of 2000 in Turkey to that in United States?
Your answer should be very brief. 0.04. What is the ratio of the PFC emissions (in thousand metric tons of CO2 equivalent) of 2005 in Turkey to that in United States?
Give a very brief answer. 0.06. What is the ratio of the PFC emissions (in thousand metric tons of CO2 equivalent) in 2008 in Turkey to that in United States?
Offer a very short reply. 0.07. What is the ratio of the PFC emissions (in thousand metric tons of CO2 equivalent) of 1990 in Turkey to that in Venezuela?
Ensure brevity in your answer.  0.28. What is the ratio of the PFC emissions (in thousand metric tons of CO2 equivalent) in 2000 in Turkey to that in Venezuela?
Your answer should be compact. 1.19. What is the ratio of the PFC emissions (in thousand metric tons of CO2 equivalent) in 2005 in Turkey to that in Venezuela?
Offer a terse response. 1.91. What is the ratio of the PFC emissions (in thousand metric tons of CO2 equivalent) in 2008 in Turkey to that in Venezuela?
Ensure brevity in your answer.  2.08. What is the ratio of the PFC emissions (in thousand metric tons of CO2 equivalent) in 1990 in Ukraine to that in United Arab Emirates?
Provide a succinct answer. 0.58. What is the ratio of the PFC emissions (in thousand metric tons of CO2 equivalent) in 2000 in Ukraine to that in United Arab Emirates?
Offer a very short reply. 1.12. What is the ratio of the PFC emissions (in thousand metric tons of CO2 equivalent) in 2005 in Ukraine to that in United Arab Emirates?
Make the answer very short. 0.67. What is the ratio of the PFC emissions (in thousand metric tons of CO2 equivalent) in 2008 in Ukraine to that in United Arab Emirates?
Offer a very short reply. 0.52. What is the ratio of the PFC emissions (in thousand metric tons of CO2 equivalent) of 1990 in Ukraine to that in United Kingdom?
Offer a very short reply. 0.14. What is the ratio of the PFC emissions (in thousand metric tons of CO2 equivalent) in 2000 in Ukraine to that in United Kingdom?
Your answer should be compact. 0.27. What is the ratio of the PFC emissions (in thousand metric tons of CO2 equivalent) of 2005 in Ukraine to that in United Kingdom?
Give a very brief answer. 0.31. What is the ratio of the PFC emissions (in thousand metric tons of CO2 equivalent) in 2008 in Ukraine to that in United Kingdom?
Your response must be concise. 0.37. What is the ratio of the PFC emissions (in thousand metric tons of CO2 equivalent) in 1990 in Ukraine to that in United States?
Offer a terse response. 0.01. What is the ratio of the PFC emissions (in thousand metric tons of CO2 equivalent) in 2000 in Ukraine to that in United States?
Ensure brevity in your answer.  0.02. What is the ratio of the PFC emissions (in thousand metric tons of CO2 equivalent) in 2005 in Ukraine to that in United States?
Your response must be concise. 0.02. What is the ratio of the PFC emissions (in thousand metric tons of CO2 equivalent) in 2008 in Ukraine to that in United States?
Offer a very short reply. 0.02. What is the ratio of the PFC emissions (in thousand metric tons of CO2 equivalent) of 1990 in Ukraine to that in Venezuela?
Offer a very short reply. 0.11. What is the ratio of the PFC emissions (in thousand metric tons of CO2 equivalent) in 2000 in Ukraine to that in Venezuela?
Keep it short and to the point. 0.53. What is the ratio of the PFC emissions (in thousand metric tons of CO2 equivalent) in 2005 in Ukraine to that in Venezuela?
Provide a succinct answer. 0.63. What is the ratio of the PFC emissions (in thousand metric tons of CO2 equivalent) of 2008 in Ukraine to that in Venezuela?
Your answer should be compact. 0.62. What is the ratio of the PFC emissions (in thousand metric tons of CO2 equivalent) in 1990 in United Arab Emirates to that in United Kingdom?
Your answer should be compact. 0.25. What is the ratio of the PFC emissions (in thousand metric tons of CO2 equivalent) of 2000 in United Arab Emirates to that in United Kingdom?
Make the answer very short. 0.24. What is the ratio of the PFC emissions (in thousand metric tons of CO2 equivalent) of 2005 in United Arab Emirates to that in United Kingdom?
Your response must be concise. 0.45. What is the ratio of the PFC emissions (in thousand metric tons of CO2 equivalent) of 2008 in United Arab Emirates to that in United Kingdom?
Your response must be concise. 0.71. What is the ratio of the PFC emissions (in thousand metric tons of CO2 equivalent) in 1990 in United Arab Emirates to that in United States?
Give a very brief answer. 0.02. What is the ratio of the PFC emissions (in thousand metric tons of CO2 equivalent) of 2000 in United Arab Emirates to that in United States?
Provide a succinct answer. 0.01. What is the ratio of the PFC emissions (in thousand metric tons of CO2 equivalent) in 2005 in United Arab Emirates to that in United States?
Your answer should be very brief. 0.03. What is the ratio of the PFC emissions (in thousand metric tons of CO2 equivalent) in 2008 in United Arab Emirates to that in United States?
Your response must be concise. 0.04. What is the ratio of the PFC emissions (in thousand metric tons of CO2 equivalent) of 1990 in United Arab Emirates to that in Venezuela?
Ensure brevity in your answer.  0.2. What is the ratio of the PFC emissions (in thousand metric tons of CO2 equivalent) in 2000 in United Arab Emirates to that in Venezuela?
Give a very brief answer. 0.47. What is the ratio of the PFC emissions (in thousand metric tons of CO2 equivalent) in 2005 in United Arab Emirates to that in Venezuela?
Your answer should be very brief. 0.94. What is the ratio of the PFC emissions (in thousand metric tons of CO2 equivalent) of 2008 in United Arab Emirates to that in Venezuela?
Offer a very short reply. 1.19. What is the ratio of the PFC emissions (in thousand metric tons of CO2 equivalent) in 1990 in United Kingdom to that in United States?
Make the answer very short. 0.07. What is the ratio of the PFC emissions (in thousand metric tons of CO2 equivalent) of 2000 in United Kingdom to that in United States?
Offer a terse response. 0.06. What is the ratio of the PFC emissions (in thousand metric tons of CO2 equivalent) of 2005 in United Kingdom to that in United States?
Your answer should be compact. 0.07. What is the ratio of the PFC emissions (in thousand metric tons of CO2 equivalent) in 2008 in United Kingdom to that in United States?
Provide a short and direct response. 0.06. What is the ratio of the PFC emissions (in thousand metric tons of CO2 equivalent) of 1990 in United Kingdom to that in Venezuela?
Ensure brevity in your answer.  0.8. What is the ratio of the PFC emissions (in thousand metric tons of CO2 equivalent) of 2000 in United Kingdom to that in Venezuela?
Your response must be concise. 1.92. What is the ratio of the PFC emissions (in thousand metric tons of CO2 equivalent) of 2005 in United Kingdom to that in Venezuela?
Offer a very short reply. 2.07. What is the ratio of the PFC emissions (in thousand metric tons of CO2 equivalent) of 2008 in United Kingdom to that in Venezuela?
Provide a short and direct response. 1.66. What is the ratio of the PFC emissions (in thousand metric tons of CO2 equivalent) of 1990 in United States to that in Venezuela?
Make the answer very short. 10.7. What is the ratio of the PFC emissions (in thousand metric tons of CO2 equivalent) in 2000 in United States to that in Venezuela?
Your answer should be compact. 31.72. What is the ratio of the PFC emissions (in thousand metric tons of CO2 equivalent) in 2005 in United States to that in Venezuela?
Give a very brief answer. 31.49. What is the ratio of the PFC emissions (in thousand metric tons of CO2 equivalent) in 2008 in United States to that in Venezuela?
Ensure brevity in your answer.  29.12. What is the difference between the highest and the second highest PFC emissions (in thousand metric tons of CO2 equivalent) of 1990?
Ensure brevity in your answer.  1.89e+04. What is the difference between the highest and the second highest PFC emissions (in thousand metric tons of CO2 equivalent) in 2000?
Offer a terse response. 1.38e+04. What is the difference between the highest and the second highest PFC emissions (in thousand metric tons of CO2 equivalent) of 2005?
Give a very brief answer. 8417.3. What is the difference between the highest and the second highest PFC emissions (in thousand metric tons of CO2 equivalent) in 2008?
Make the answer very short. 7672.6. What is the difference between the highest and the lowest PFC emissions (in thousand metric tons of CO2 equivalent) of 1990?
Provide a short and direct response. 2.06e+04. What is the difference between the highest and the lowest PFC emissions (in thousand metric tons of CO2 equivalent) of 2000?
Your answer should be compact. 1.45e+04. What is the difference between the highest and the lowest PFC emissions (in thousand metric tons of CO2 equivalent) of 2005?
Your answer should be very brief. 8828.2. What is the difference between the highest and the lowest PFC emissions (in thousand metric tons of CO2 equivalent) of 2008?
Your answer should be very brief. 8087.5. 